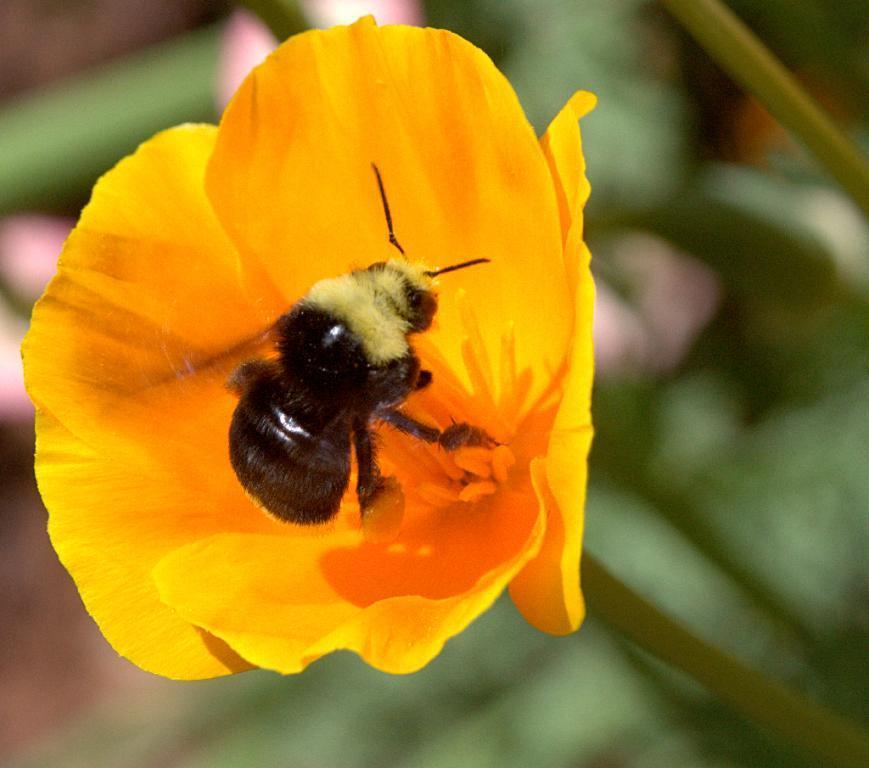Please provide a concise description of this image. In the center of the image we can see a bug on the flower. 